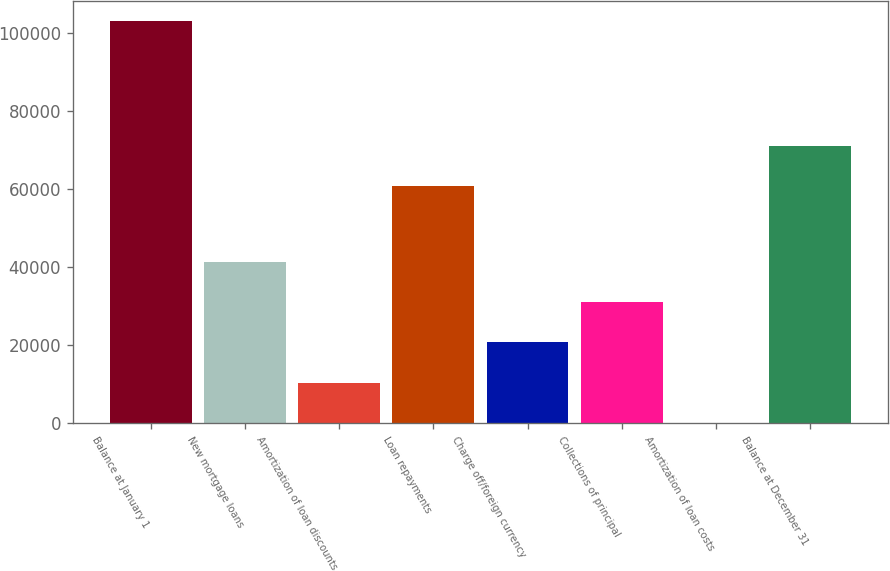Convert chart. <chart><loc_0><loc_0><loc_500><loc_500><bar_chart><fcel>Balance at January 1<fcel>New mortgage loans<fcel>Amortization of loan discounts<fcel>Loan repayments<fcel>Charge off/foreign currency<fcel>Collections of principal<fcel>Amortization of loan costs<fcel>Balance at December 31<nl><fcel>102972<fcel>41222.4<fcel>10347.6<fcel>60740<fcel>20639.2<fcel>30930.8<fcel>56<fcel>71031.6<nl></chart> 